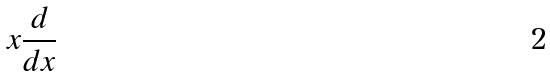Convert formula to latex. <formula><loc_0><loc_0><loc_500><loc_500>x \frac { d } { d x }</formula> 